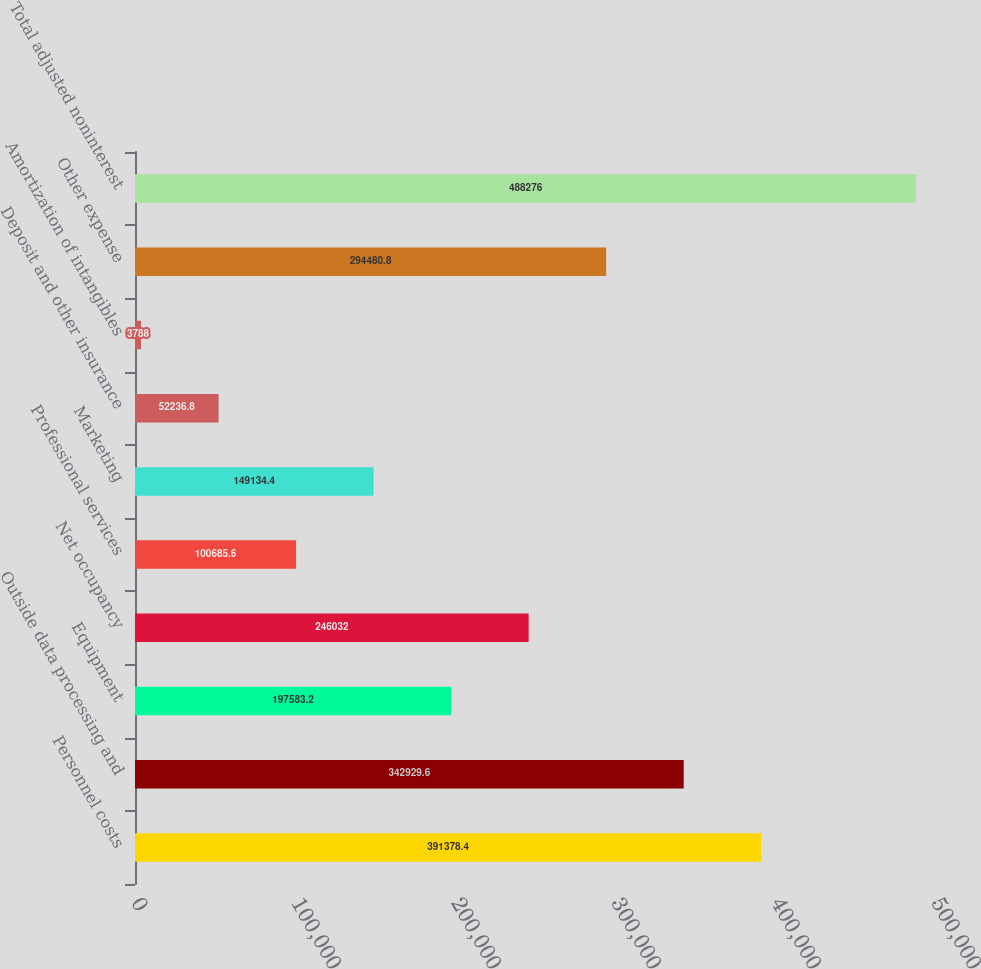Convert chart to OTSL. <chart><loc_0><loc_0><loc_500><loc_500><bar_chart><fcel>Personnel costs<fcel>Outside data processing and<fcel>Equipment<fcel>Net occupancy<fcel>Professional services<fcel>Marketing<fcel>Deposit and other insurance<fcel>Amortization of intangibles<fcel>Other expense<fcel>Total adjusted noninterest<nl><fcel>391378<fcel>342930<fcel>197583<fcel>246032<fcel>100686<fcel>149134<fcel>52236.8<fcel>3788<fcel>294481<fcel>488276<nl></chart> 